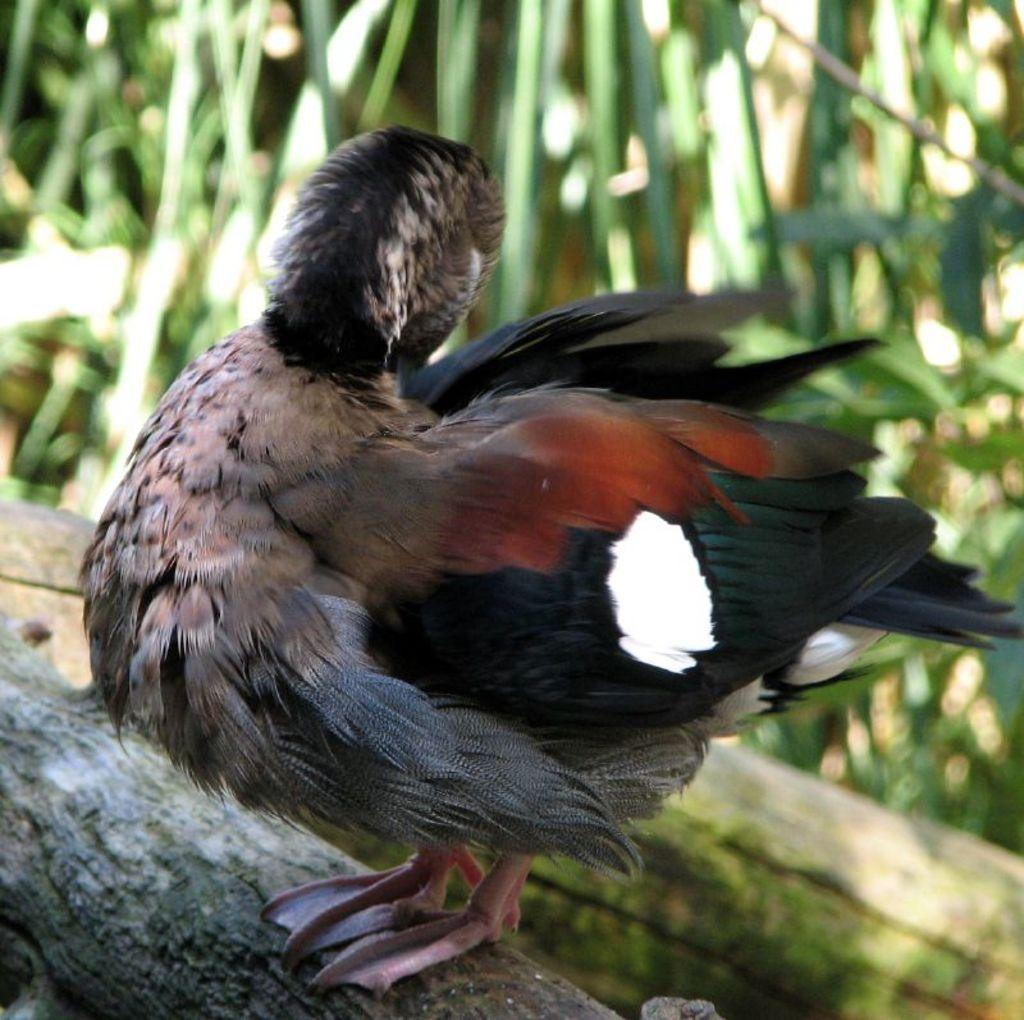What animal is present in the image? There is a duck in the image. Where is the duck located? The duck is on tree bark. What can be seen in the background of the image? There are plants in the background of the image. What flavor of fiction is the duck reading in the image? There is no fiction or reading material present in the image; it features a duck on tree bark with plants in the background. 